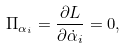Convert formula to latex. <formula><loc_0><loc_0><loc_500><loc_500>\Pi _ { \alpha _ { i } } = \frac { \partial L } { \partial \dot { \alpha } _ { i } } = 0 ,</formula> 